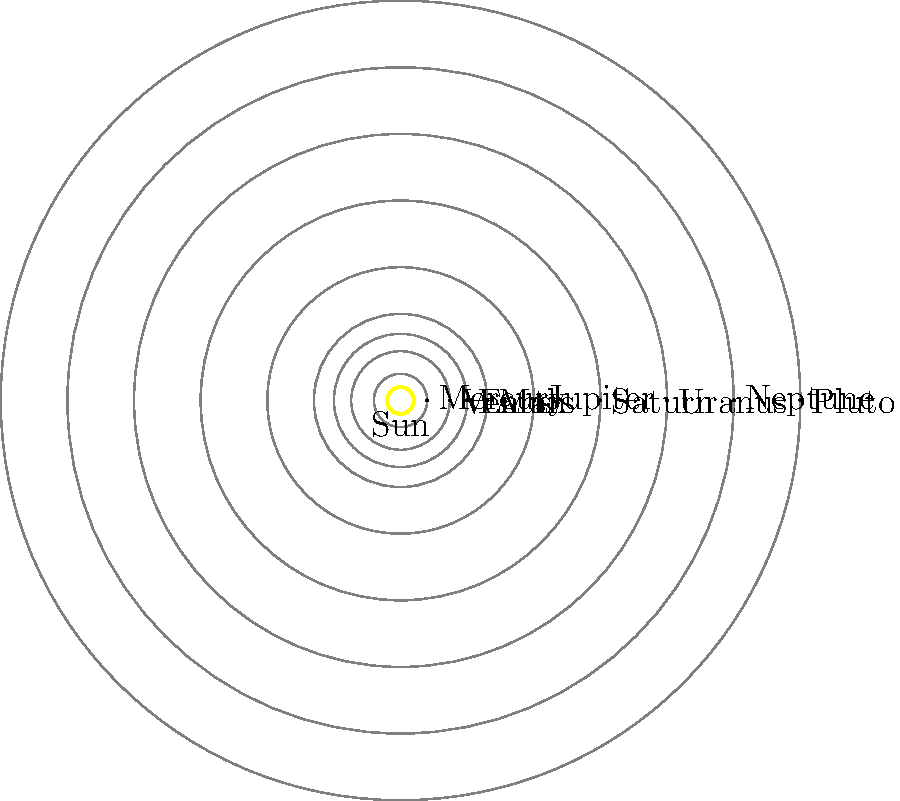As a DJ, you often incorporate cosmic themes into your sets. Looking at this diagram of our solar system, which planet would best represent the "drop" in your space-themed track, given its position relative to the inner and outer planets? To answer this question, let's analyze the layout of the solar system:

1. The inner planets (Mercury, Venus, Earth, and Mars) are closer to the Sun and relatively small.
2. The outer planets (Jupiter, Saturn, Uranus, and Neptune) are farther from the Sun and generally larger.
3. Pluto, while no longer considered a planet, is the farthest object shown.

4. Jupiter stands out as it:
   a) Is the first of the outer planets
   b) Is significantly larger than the inner planets
   c) Marks a clear transition between the inner and outer solar system

5. In music production, the "drop" is a dramatic shift in a track, often signaling a change in energy or intensity.

6. Jupiter's position and significance in the solar system mirror the function of a "drop" in music:
   a) It marks a dramatic shift from the smaller, rocky inner planets to the larger, gaseous outer planets
   b) Its size and position make it stand out, much like how a drop stands out in a track

7. Therefore, Jupiter would best represent the "drop" in a space-themed track, as it signifies a major transition in the solar system's layout, much like how a drop signifies a major transition in a music track.
Answer: Jupiter 